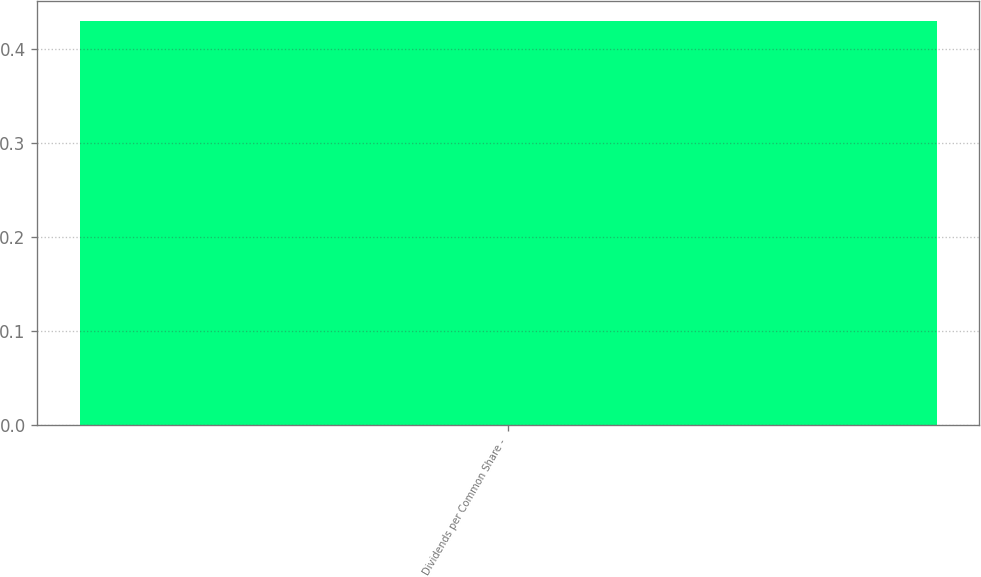<chart> <loc_0><loc_0><loc_500><loc_500><bar_chart><fcel>Dividends per Common Share -<nl><fcel>0.43<nl></chart> 